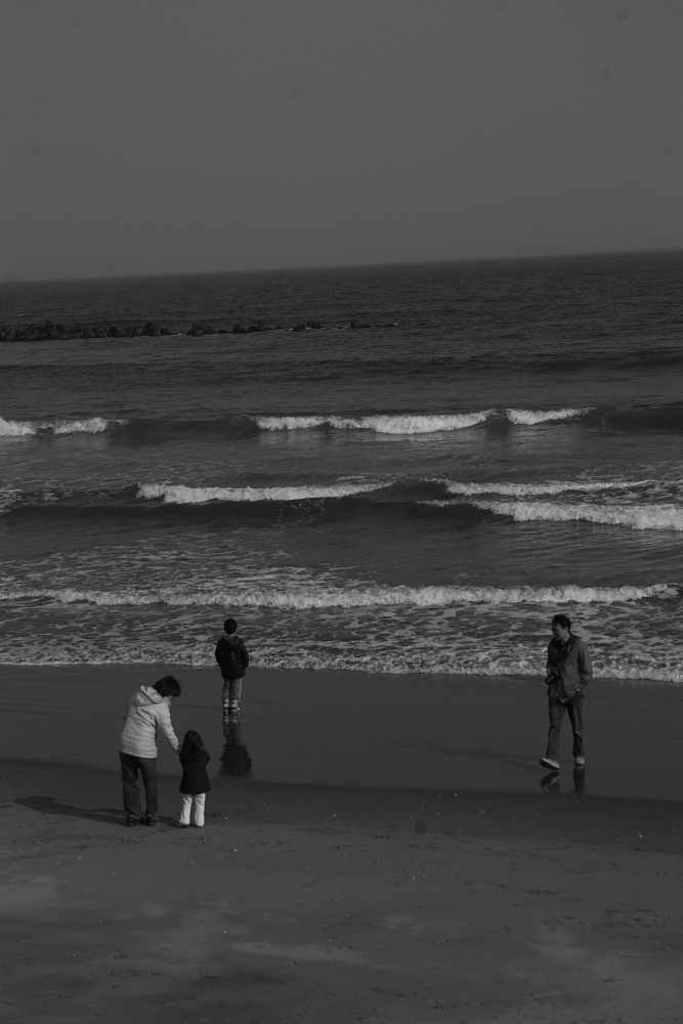What can be seen in the image? There are people standing in the image. Where are the people standing in relation to the water? The people are standing in front of the water. What is visible in the background of the image? The sky is visible in the background of the image. What type of prose is being recited by the people in the image? There is no indication in the image that the people are reciting any prose. 